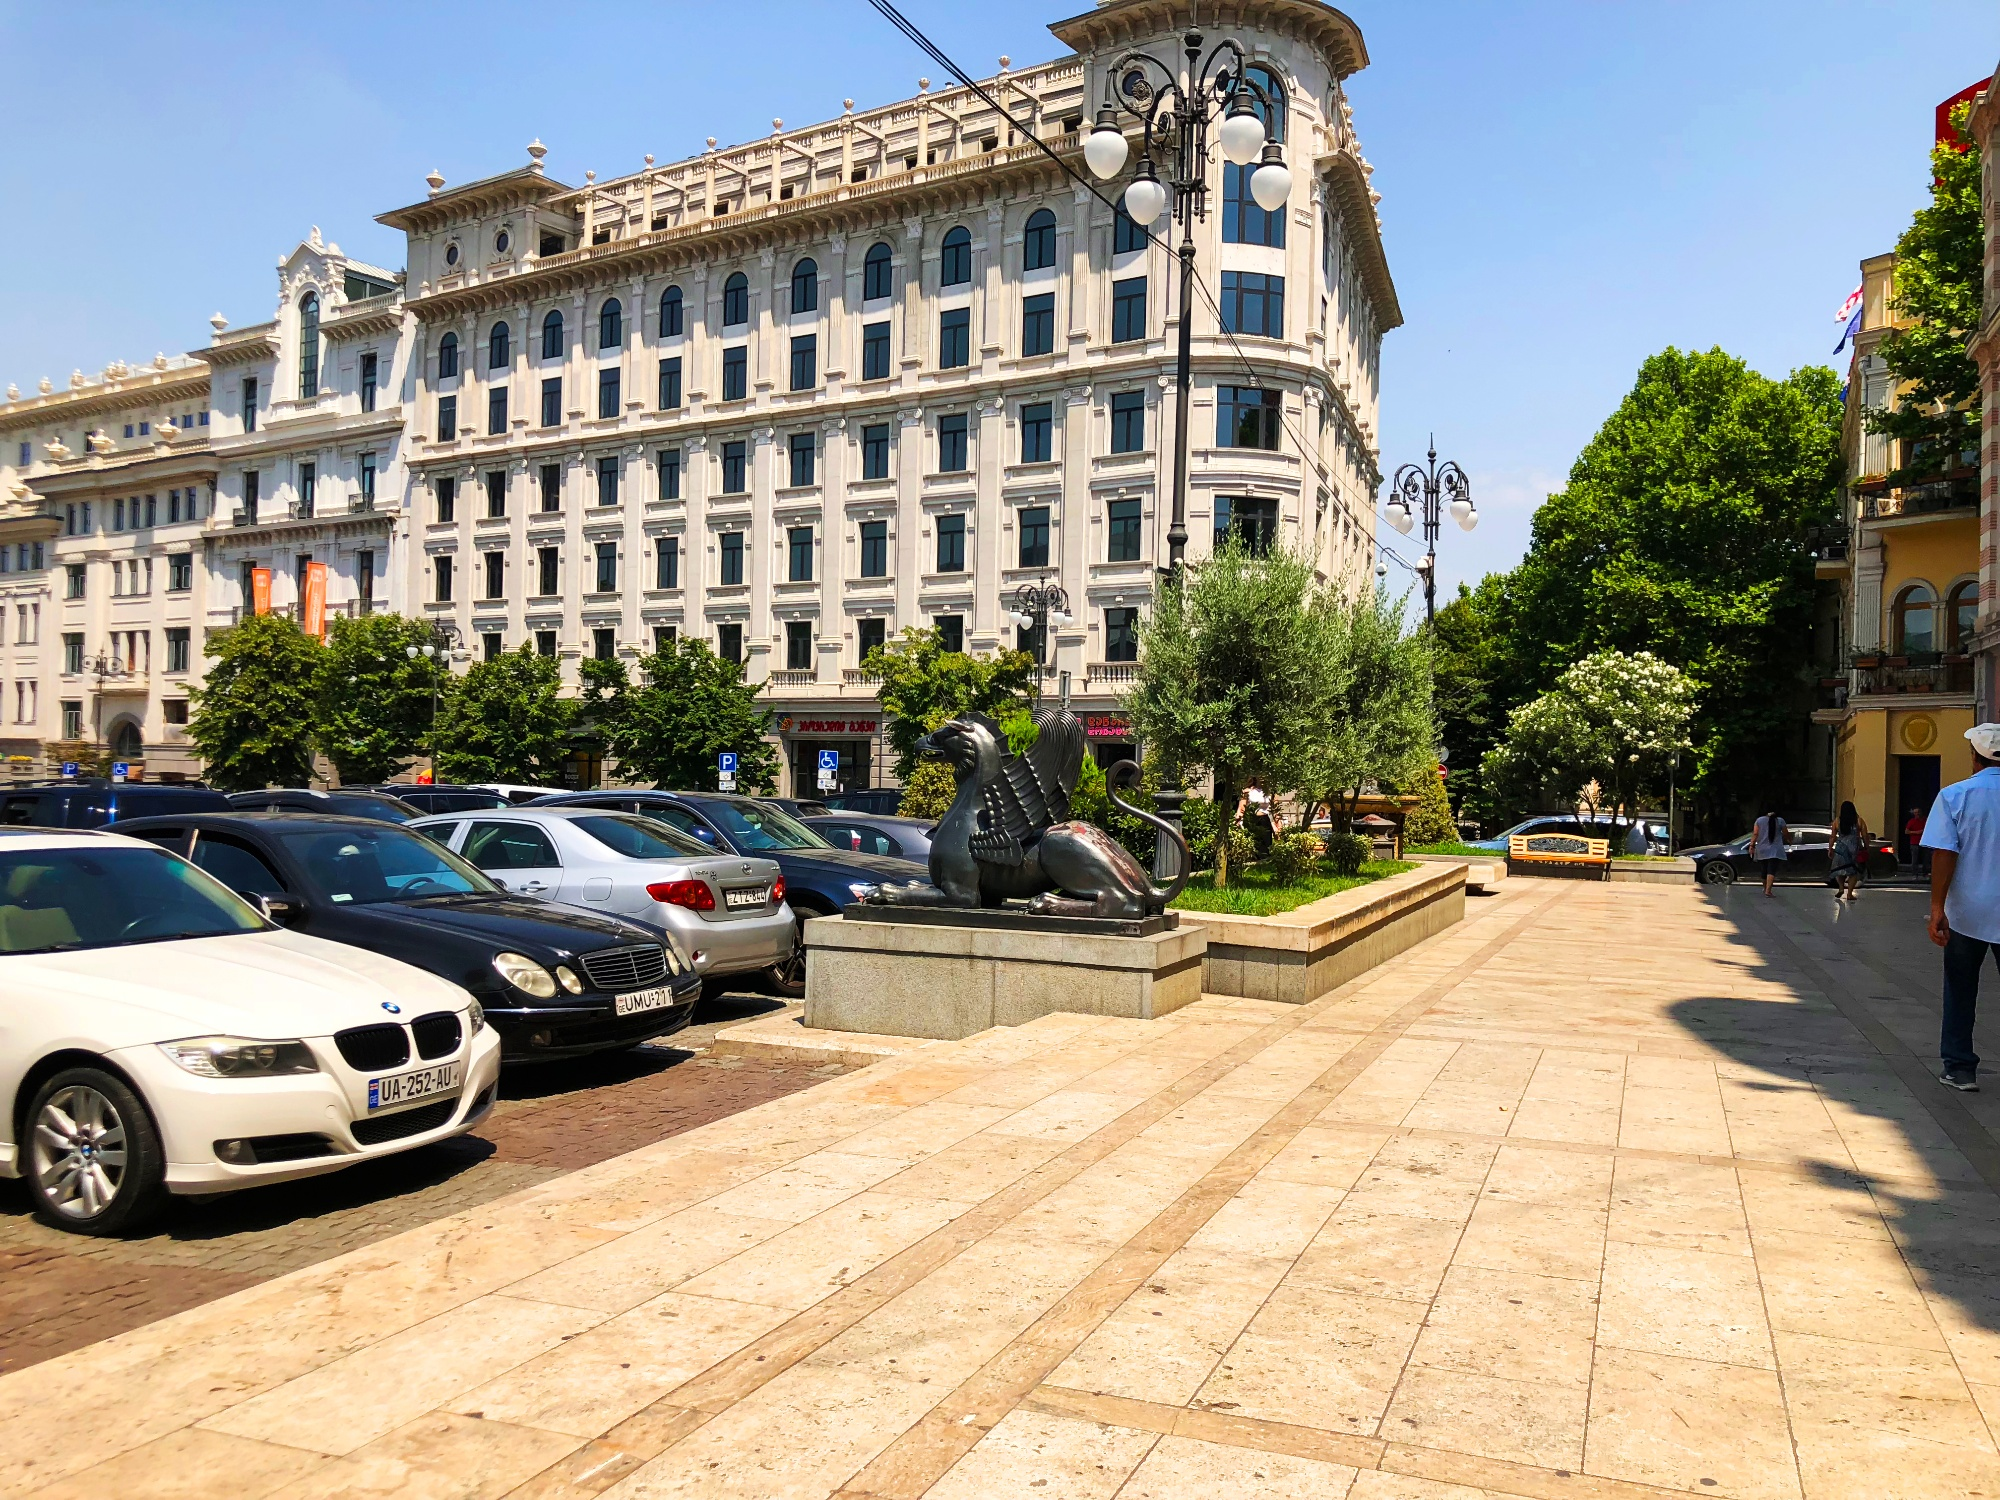Write a detailed description of the given image. The image portrays a lively urban landscape on what appears to be a sunny day. Dominating the view is an imposing white building with ornate façades and decorative moldings, capturing the essence of classic European architecture. This majestic structure, along with others in the vicinity, lends the area an elegant and historic feel. 

The foreground is bustling with modern vehicles parked alongside the paved walkway, showcasing a juxtaposition of contemporary life against the old-world charm. As we glance over the polished surfaces of the cars, including a white BMW, the reflection of light hints at the current weather conditions. 

To the right of the frame, a statue of a lion seated on a pedestal stands proudly, complementing the grandeur of its surroundings. Throughout, we observe people going about their day with one man strolling by the lion sculpture, possibly appreciating the scene or simply heading to his next destination. The verdant trees dotting the area offer pockets of nature amidst the urban setting. Overall, the photograph is a rich tapestry of city life where tradition and progress coexist harmoniously. 